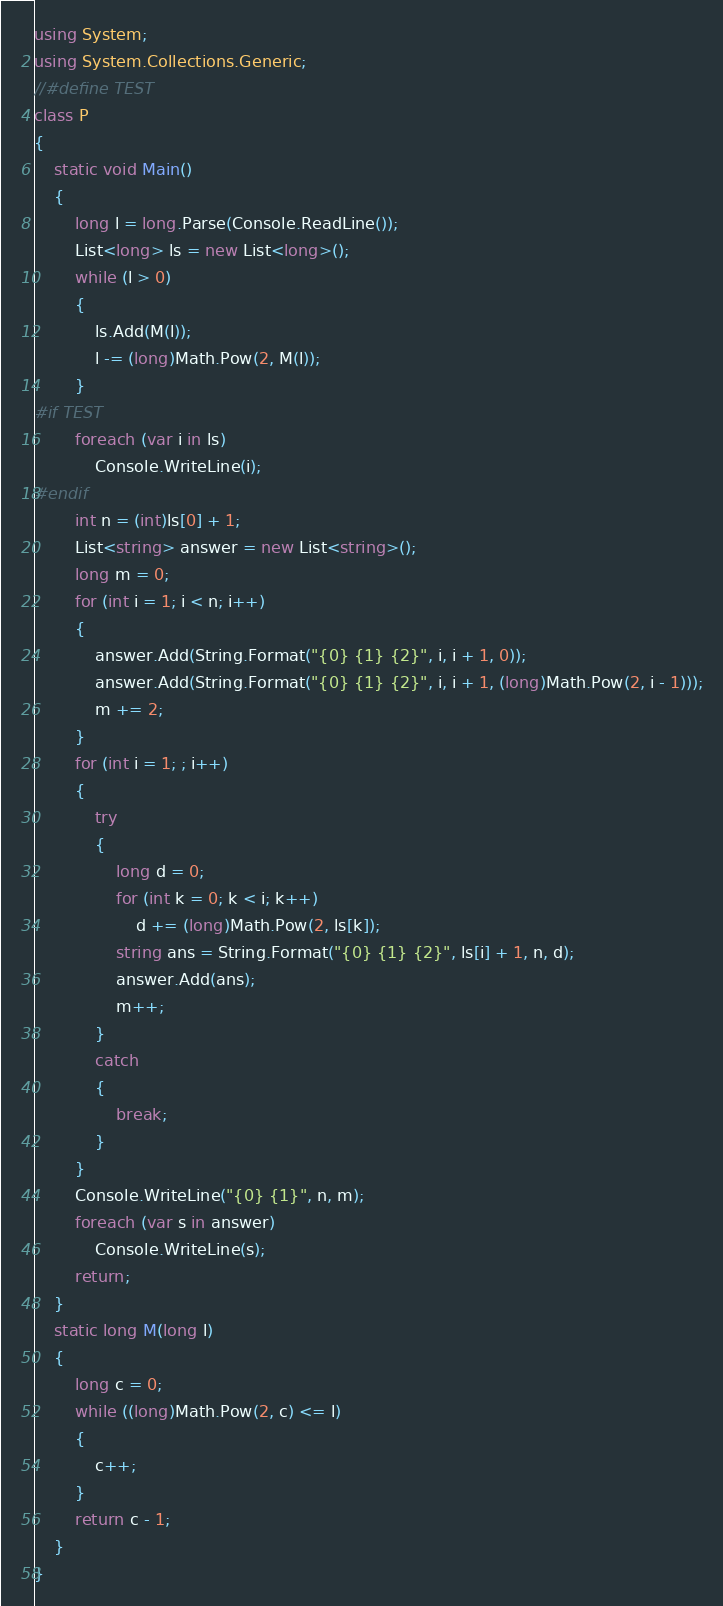<code> <loc_0><loc_0><loc_500><loc_500><_C#_>using System;
using System.Collections.Generic;
//#define TEST
class P
{
    static void Main()
    {
        long l = long.Parse(Console.ReadLine());
        List<long> ls = new List<long>();
        while (l > 0)
        {
            ls.Add(M(l));
            l -= (long)Math.Pow(2, M(l));
        }
#if TEST
        foreach (var i in ls)
            Console.WriteLine(i);
#endif
        int n = (int)ls[0] + 1;
        List<string> answer = new List<string>();
        long m = 0;
        for (int i = 1; i < n; i++)
        {
            answer.Add(String.Format("{0} {1} {2}", i, i + 1, 0));
            answer.Add(String.Format("{0} {1} {2}", i, i + 1, (long)Math.Pow(2, i - 1)));
            m += 2;
        }
        for (int i = 1; ; i++)
        {
            try
            {
                long d = 0;
                for (int k = 0; k < i; k++)
                    d += (long)Math.Pow(2, ls[k]);
                string ans = String.Format("{0} {1} {2}", ls[i] + 1, n, d);
                answer.Add(ans);
                m++;
            }
            catch
            {
                break;
            }
        }
        Console.WriteLine("{0} {1}", n, m);
        foreach (var s in answer)
            Console.WriteLine(s);
        return;
    }
    static long M(long l)
    {
        long c = 0;
        while ((long)Math.Pow(2, c) <= l)
        {
            c++;
        }
        return c - 1;
    }
}</code> 